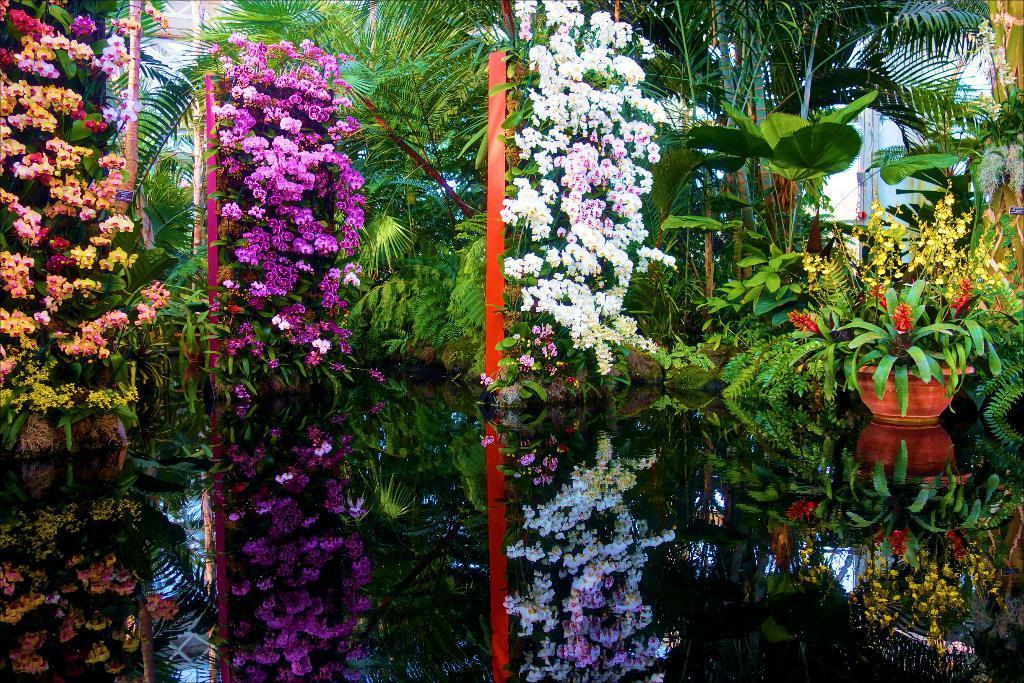Describe this image in one or two sentences. Here in this picture we can see number of flowers present on the plants and we can also see trees present and we can also see plant pots present and in the front we can see water present and we can see reflection in the water. 